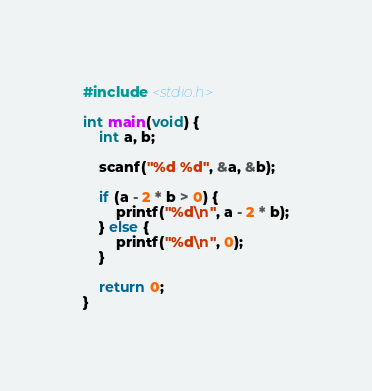<code> <loc_0><loc_0><loc_500><loc_500><_C_>#include <stdio.h>

int main(void) {
    int a, b;

    scanf("%d %d", &a, &b);

    if (a - 2 * b > 0) {
        printf("%d\n", a - 2 * b);
    } else {
        printf("%d\n", 0);
    }

    return 0;
}
</code> 